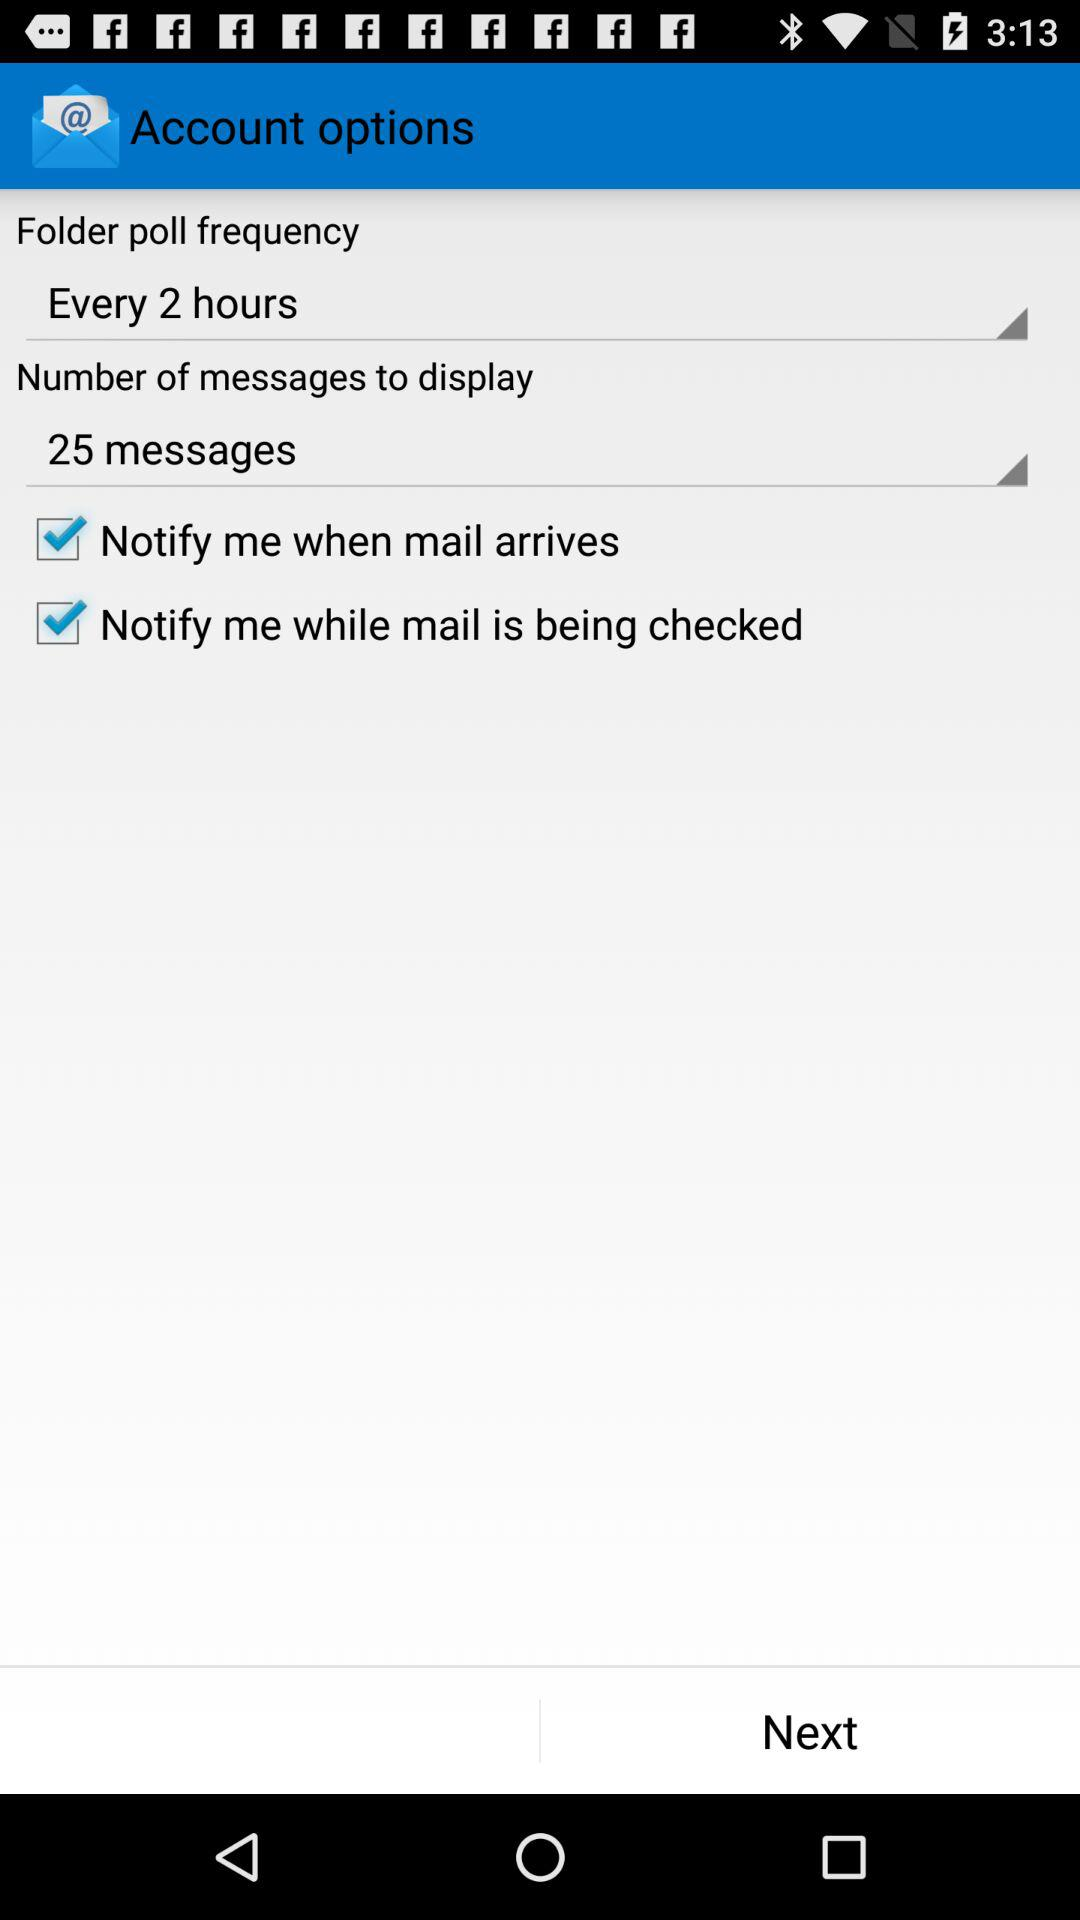What is the number of messages that need to be displayed? The number of messages that need to be displayed is 25. 